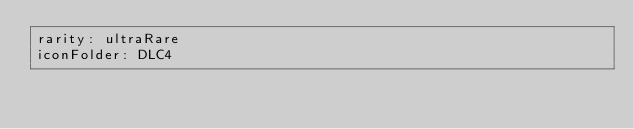<code> <loc_0><loc_0><loc_500><loc_500><_YAML_>rarity: ultraRare
iconFolder: DLC4</code> 